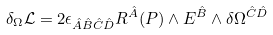<formula> <loc_0><loc_0><loc_500><loc_500>\delta _ { \Omega } \mathcal { L } & = 2 \epsilon _ { \hat { A } \hat { B } \hat { C } \hat { D } } R ^ { \hat { A } } ( P ) \wedge E ^ { \hat { B } } \wedge \delta \Omega ^ { \hat { C } \hat { D } }</formula> 